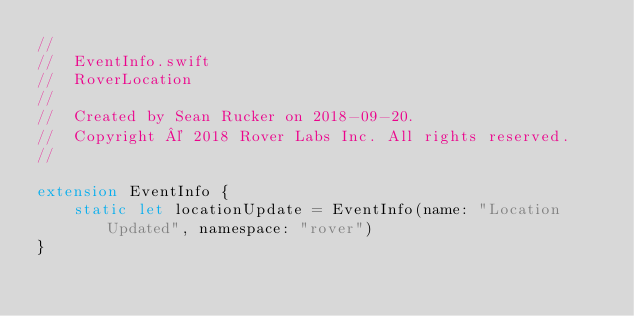Convert code to text. <code><loc_0><loc_0><loc_500><loc_500><_Swift_>//
//  EventInfo.swift
//  RoverLocation
//
//  Created by Sean Rucker on 2018-09-20.
//  Copyright © 2018 Rover Labs Inc. All rights reserved.
//

extension EventInfo {
    static let locationUpdate = EventInfo(name: "Location Updated", namespace: "rover")
}
</code> 